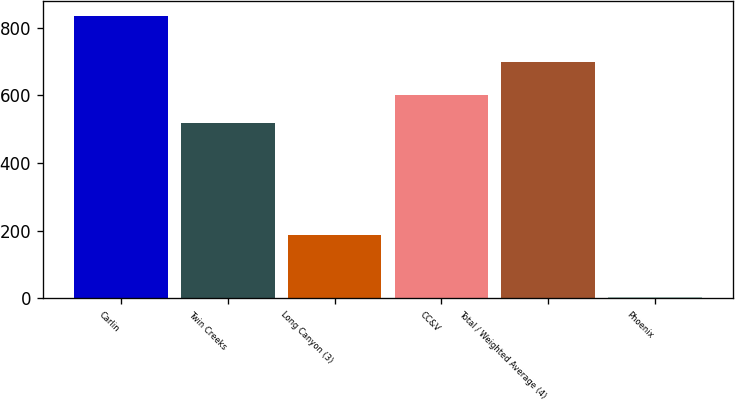Convert chart to OTSL. <chart><loc_0><loc_0><loc_500><loc_500><bar_chart><fcel>Carlin<fcel>Twin Creeks<fcel>Long Canyon (3)<fcel>CC&V<fcel>Total / Weighted Average (4)<fcel>Phoenix<nl><fcel>836<fcel>517<fcel>186<fcel>600.38<fcel>699<fcel>2.23<nl></chart> 